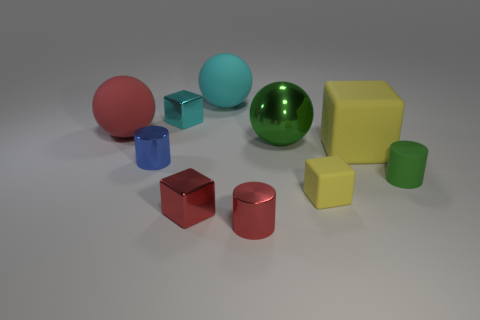Subtract all cylinders. How many objects are left? 7 Add 9 red cylinders. How many red cylinders are left? 10 Add 5 big red matte objects. How many big red matte objects exist? 6 Subtract 1 red spheres. How many objects are left? 9 Subtract all big shiny objects. Subtract all small cylinders. How many objects are left? 6 